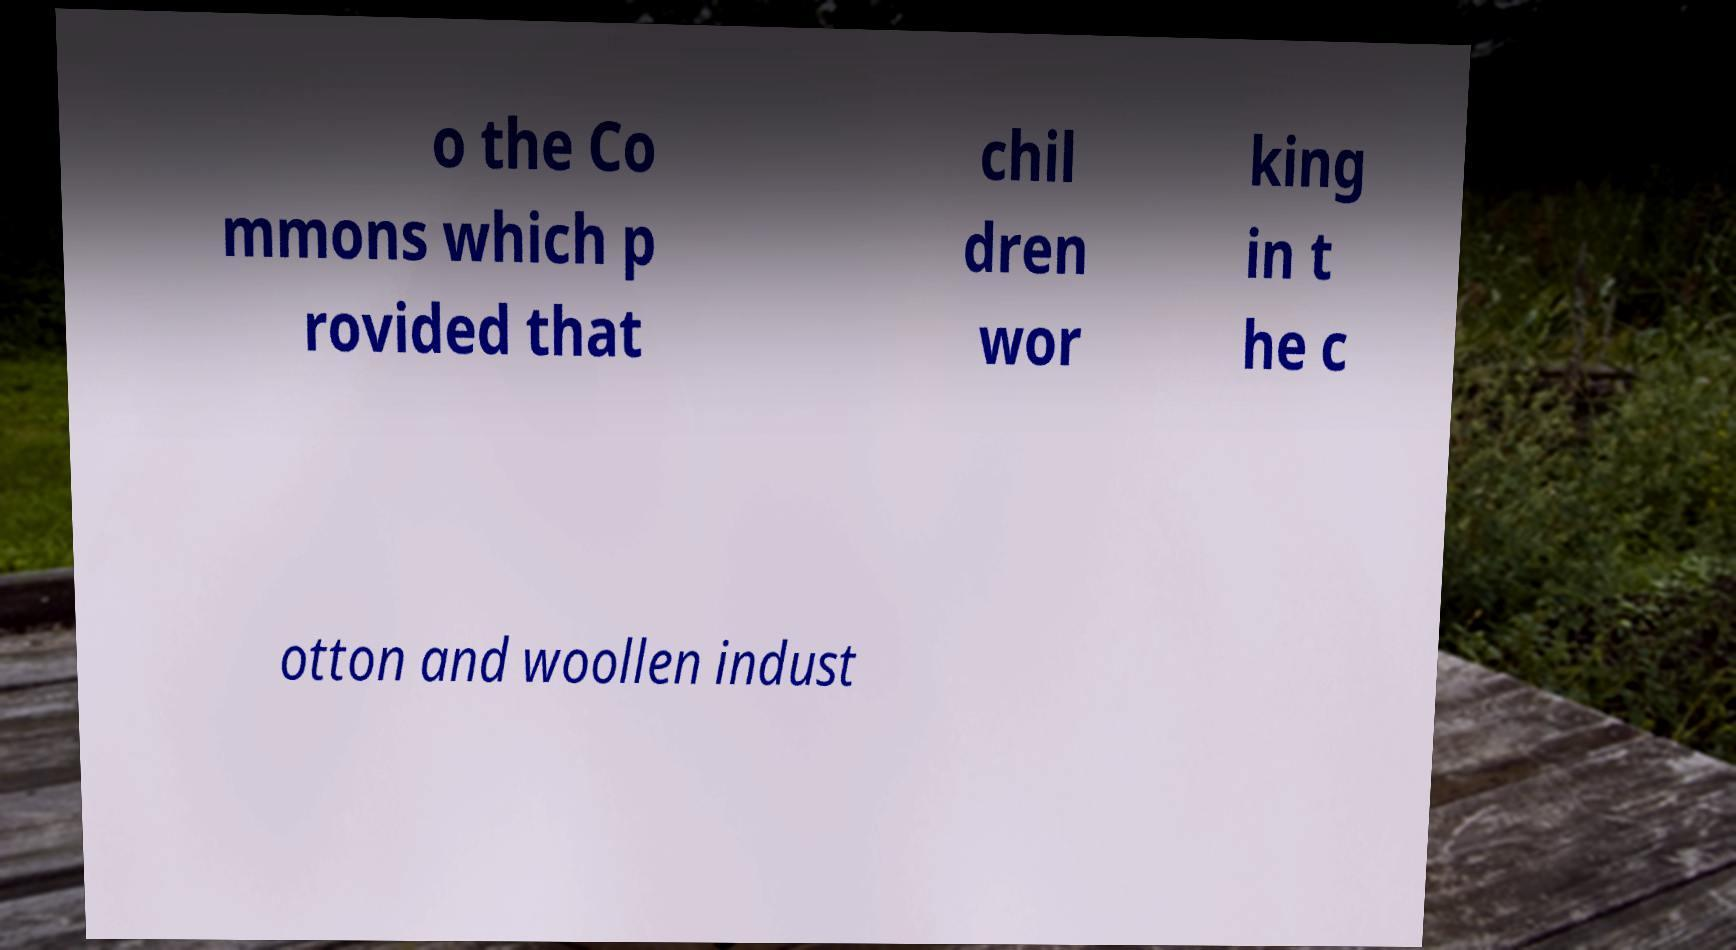Please identify and transcribe the text found in this image. o the Co mmons which p rovided that chil dren wor king in t he c otton and woollen indust 